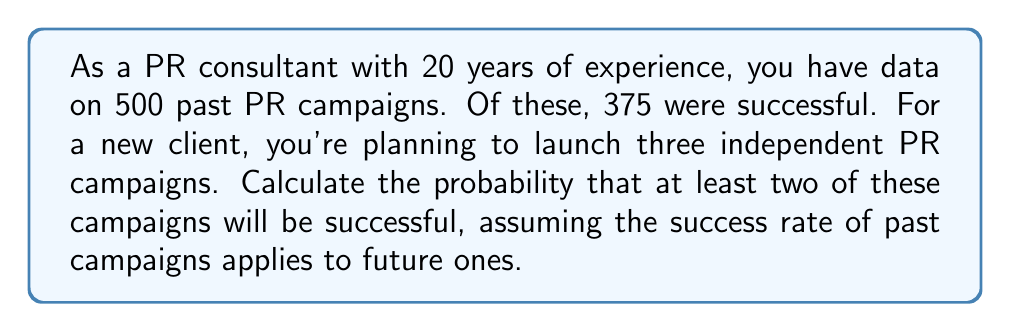Help me with this question. Let's approach this step-by-step:

1) First, we need to calculate the probability of success for a single campaign based on historical data:

   $P(\text{success}) = \frac{\text{number of successful campaigns}}{\text{total number of campaigns}} = \frac{375}{500} = 0.75$ or 75%

2) Now, we can define our random variable X as the number of successful campaigns out of the three planned. X follows a binomial distribution with n = 3 (number of trials) and p = 0.75 (probability of success for each trial).

3) We want to find $P(X \geq 2)$, which is equivalent to $1 - P(X < 2)$ or $1 - [P(X=0) + P(X=1)]$

4) The probability mass function for a binomial distribution is:

   $P(X = k) = \binom{n}{k} p^k (1-p)^{n-k}$

   where $\binom{n}{k}$ is the binomial coefficient.

5) Let's calculate $P(X=0)$ and $P(X=1)$:

   $P(X=0) = \binom{3}{0} (0.75)^0 (0.25)^3 = 1 \cdot 1 \cdot 0.015625 = 0.015625$

   $P(X=1) = \binom{3}{1} (0.75)^1 (0.25)^2 = 3 \cdot 0.75 \cdot 0.0625 = 0.140625$

6) Now we can calculate our final probability:

   $P(X \geq 2) = 1 - [P(X=0) + P(X=1)]$
                $= 1 - [0.015625 + 0.140625]$
                $= 1 - 0.15625$
                $= 0.84375$

Therefore, the probability that at least two of the three campaigns will be successful is 0.84375 or 84.375%.
Answer: 0.84375 or 84.375% 